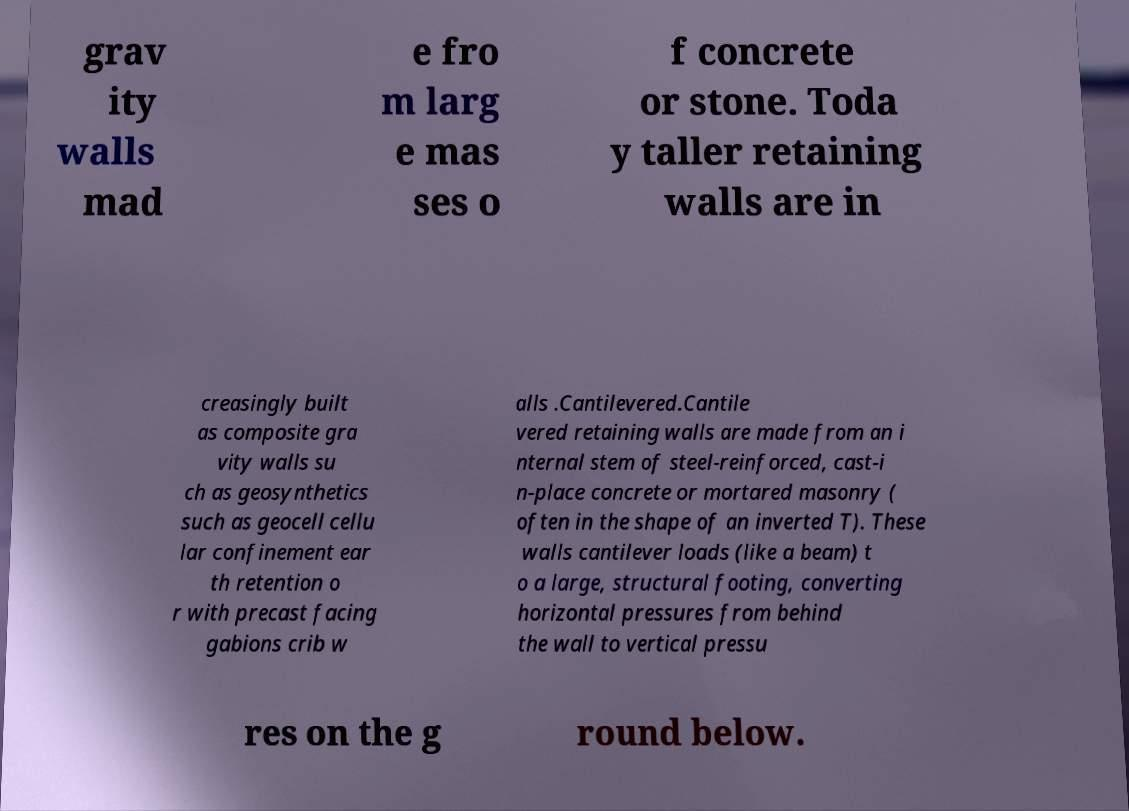Can you read and provide the text displayed in the image?This photo seems to have some interesting text. Can you extract and type it out for me? grav ity walls mad e fro m larg e mas ses o f concrete or stone. Toda y taller retaining walls are in creasingly built as composite gra vity walls su ch as geosynthetics such as geocell cellu lar confinement ear th retention o r with precast facing gabions crib w alls .Cantilevered.Cantile vered retaining walls are made from an i nternal stem of steel-reinforced, cast-i n-place concrete or mortared masonry ( often in the shape of an inverted T). These walls cantilever loads (like a beam) t o a large, structural footing, converting horizontal pressures from behind the wall to vertical pressu res on the g round below. 